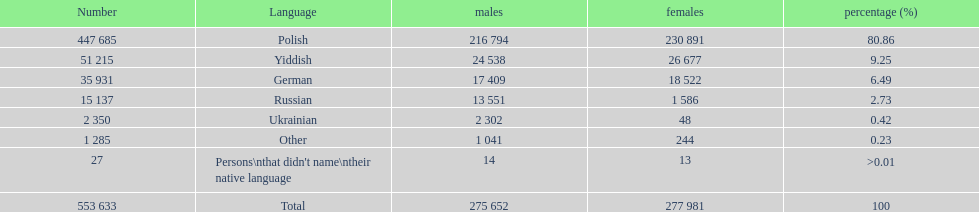How many male and female german speakers are there? 35931. 